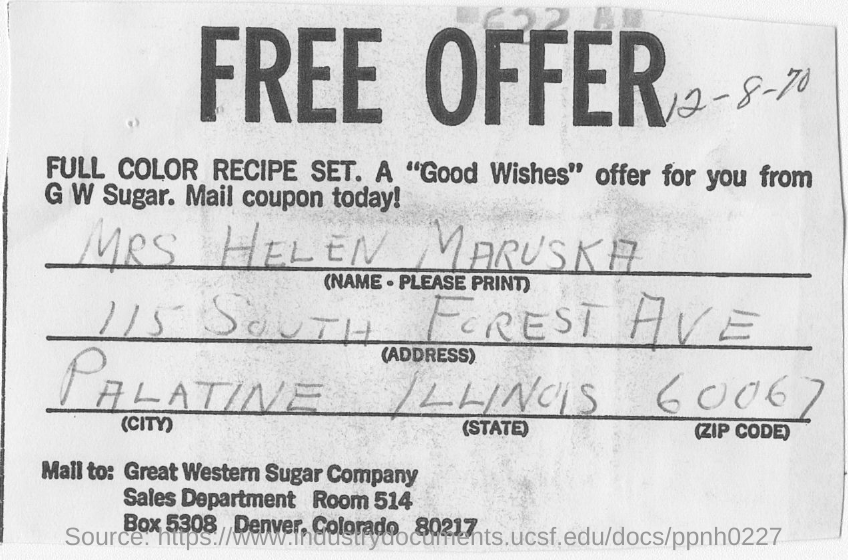Where is the Great Western Sugar Company located?
Keep it short and to the point. DENVER, COLORADO. 